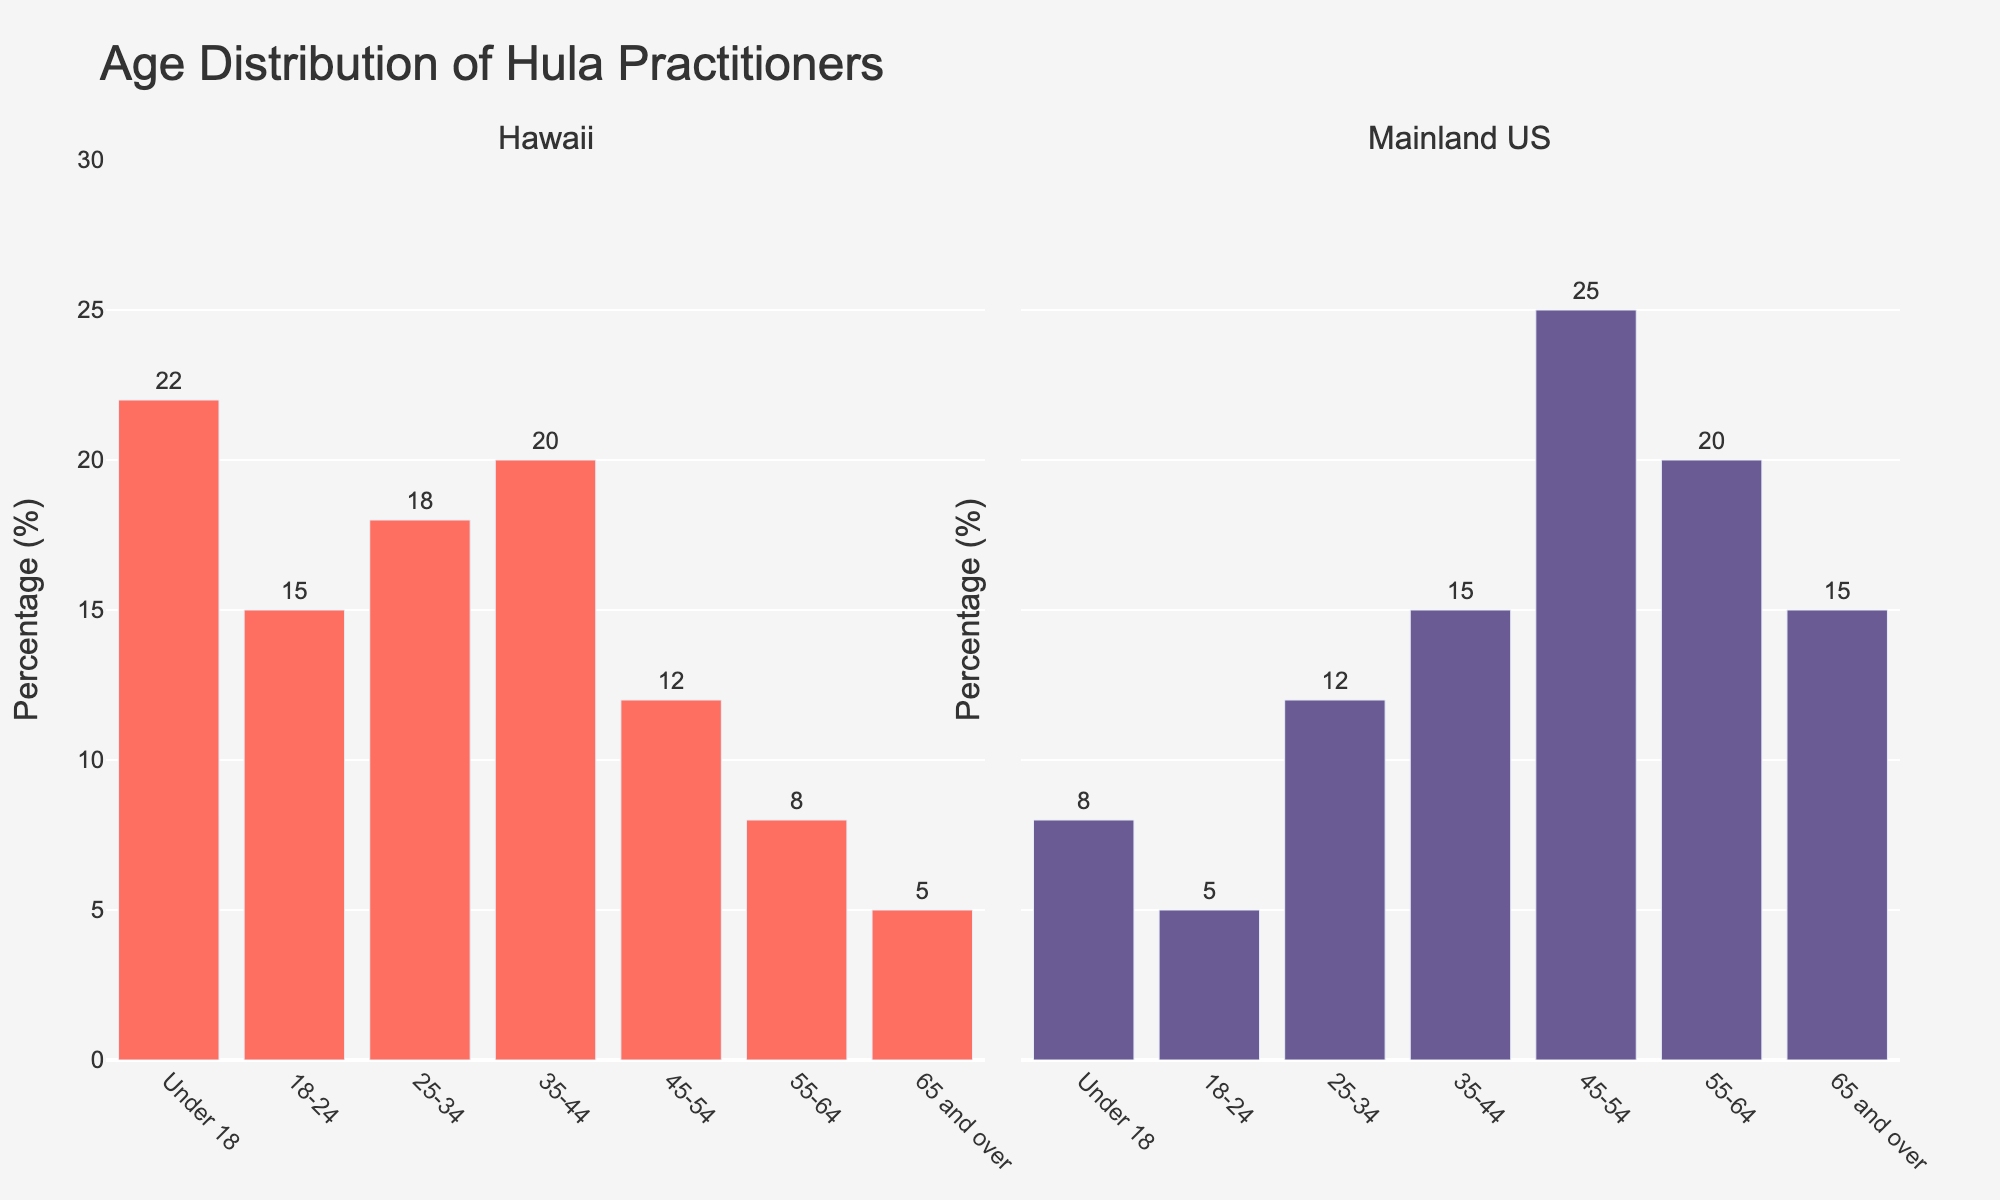What percentage of hula practitioners in Hawaii are aged 18-24? Look for the bar labeled '18-24' in the Hawaii subplot. The bar's text label shows the percentage.
Answer: 15% Which age group has the highest percentage of hula practitioners in the Mainland US? Compare the height or the text values of all bars in the Mainland US subplot. The bar with the highest value represents the age group with the highest percentage.
Answer: 45-54 What is the difference in the percentage of hula practitioners aged 55-64 between Hawaii and the Mainland US? Find the bars labeled '55-64' in both subplots and note their percentages. Subtract the value for Hawaii from the Mainland US.
Answer: 12% Which region has a higher percentage of hula practitioners aged under 18? Compare the bars labeled 'Under 18' in both subplots by their height or value. The higher bar represents the region with a higher percentage.
Answer: Hawaii What's the sum of the percentages of hula practitioners aged 25-34 and 35-44 in Hawaii? Find the bars labeled '25-34' and '35-44' in the Hawaii subplot and sum their percentages: 18% + 20% = 38%
Answer: 38% Is the percentage of hula practitioners aged 65 and over higher in Hawaii or the Mainland US? Compare the bars labeled '65 and over' in both subplots by their height or value. The higher bar indicates the region with the higher percentage.
Answer: Mainland US How many age groups in Hawaii have a percentage of hula practitioners that exceeds 15%? Count the bars in the Hawaii subplot where the value exceeds 15%.
Answer: 3 What's the average percentage of hula practitioners aged 45-54 and 55-64 in the Mainland US? Find the bars labeled '45-54' and '55-64' in the Mainland US subplot. Add their percentages and divide by 2: (25% + 20%) / 2 = 22.5%
Answer: 22.5% Which age group has the same percentage of hula practitioners in both Hawaii and the Mainland US? Check for bars in both subplots that have the same value.
Answer: None Is the age distribution of hula practitioners more evenly spread out in Hawaii or the Mainland US? Compare the heights of bars across all age groups in both subplots to determine which region has a more even spread. The region with more similar bar heights represents a more even distribution.
Answer: Hawaii 